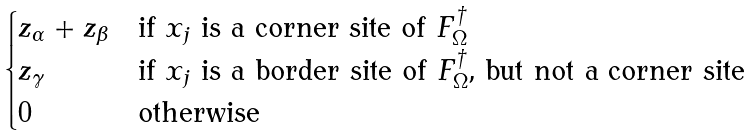<formula> <loc_0><loc_0><loc_500><loc_500>\begin{cases} z _ { \alpha } + z _ { \beta } & \text {if $x_{j}$ is a corner site of $F^{\dag}_{\Omega}$} \\ z _ { \gamma } & \text {if $x_{j}$ is a border site of $F^{\dag}_{\Omega}$, but not a corner site} \\ 0 & \text {otherwise} \end{cases}</formula> 